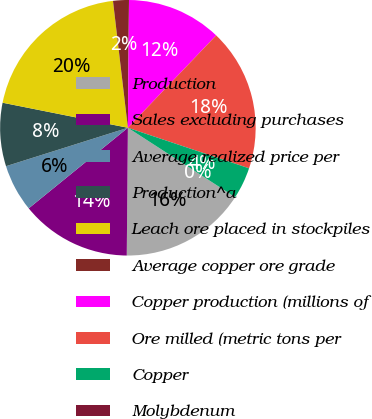Convert chart to OTSL. <chart><loc_0><loc_0><loc_500><loc_500><pie_chart><fcel>Production<fcel>Sales excluding purchases<fcel>Average realized price per<fcel>Production^a<fcel>Leach ore placed in stockpiles<fcel>Average copper ore grade<fcel>Copper production (millions of<fcel>Ore milled (metric tons per<fcel>Copper<fcel>Molybdenum<nl><fcel>16.0%<fcel>14.0%<fcel>6.0%<fcel>8.0%<fcel>20.0%<fcel>2.0%<fcel>12.0%<fcel>18.0%<fcel>4.0%<fcel>0.0%<nl></chart> 